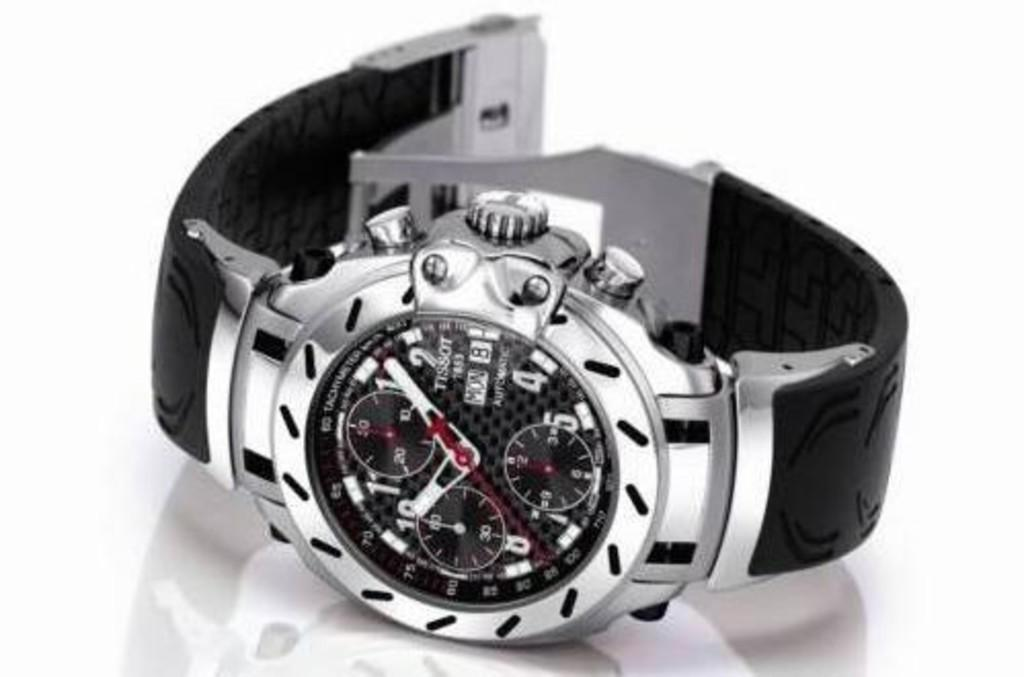<image>
Relay a brief, clear account of the picture shown. The black and silver watch is made by Tissot. 